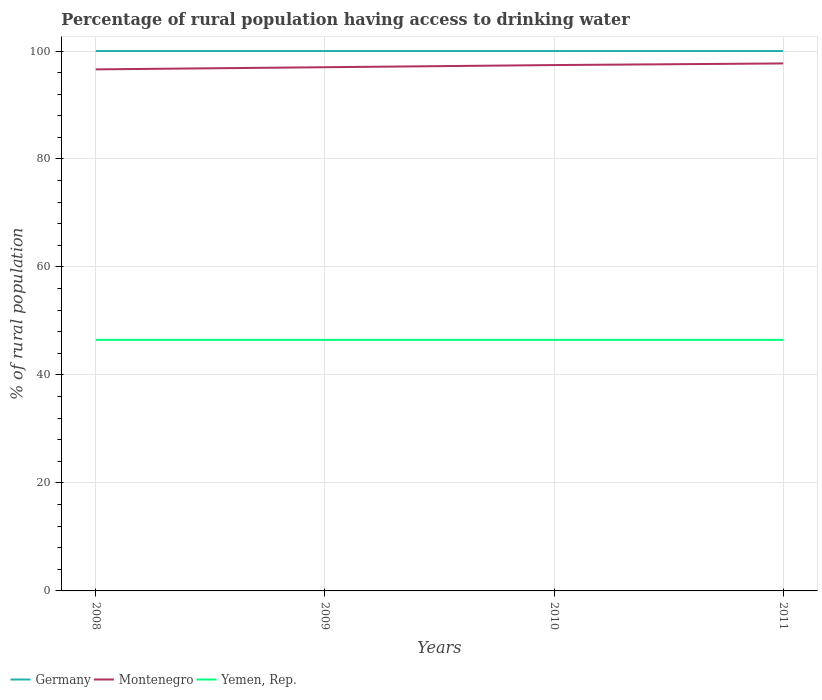Is the number of lines equal to the number of legend labels?
Provide a short and direct response. Yes. Across all years, what is the maximum percentage of rural population having access to drinking water in Montenegro?
Provide a short and direct response. 96.6. What is the total percentage of rural population having access to drinking water in Montenegro in the graph?
Give a very brief answer. -0.8. What is the difference between the highest and the second highest percentage of rural population having access to drinking water in Montenegro?
Provide a short and direct response. 1.1. What is the title of the graph?
Your response must be concise. Percentage of rural population having access to drinking water. Does "Maldives" appear as one of the legend labels in the graph?
Ensure brevity in your answer.  No. What is the label or title of the X-axis?
Offer a very short reply. Years. What is the label or title of the Y-axis?
Offer a terse response. % of rural population. What is the % of rural population of Montenegro in 2008?
Offer a terse response. 96.6. What is the % of rural population of Yemen, Rep. in 2008?
Your answer should be compact. 46.5. What is the % of rural population in Germany in 2009?
Ensure brevity in your answer.  100. What is the % of rural population in Montenegro in 2009?
Make the answer very short. 97. What is the % of rural population in Yemen, Rep. in 2009?
Your answer should be very brief. 46.5. What is the % of rural population in Montenegro in 2010?
Give a very brief answer. 97.4. What is the % of rural population of Yemen, Rep. in 2010?
Keep it short and to the point. 46.5. What is the % of rural population in Germany in 2011?
Give a very brief answer. 100. What is the % of rural population in Montenegro in 2011?
Keep it short and to the point. 97.7. What is the % of rural population in Yemen, Rep. in 2011?
Give a very brief answer. 46.5. Across all years, what is the maximum % of rural population in Montenegro?
Keep it short and to the point. 97.7. Across all years, what is the maximum % of rural population in Yemen, Rep.?
Your answer should be very brief. 46.5. Across all years, what is the minimum % of rural population in Germany?
Provide a short and direct response. 100. Across all years, what is the minimum % of rural population in Montenegro?
Ensure brevity in your answer.  96.6. Across all years, what is the minimum % of rural population of Yemen, Rep.?
Give a very brief answer. 46.5. What is the total % of rural population of Montenegro in the graph?
Offer a very short reply. 388.7. What is the total % of rural population in Yemen, Rep. in the graph?
Ensure brevity in your answer.  186. What is the difference between the % of rural population of Germany in 2008 and that in 2009?
Provide a succinct answer. 0. What is the difference between the % of rural population in Yemen, Rep. in 2008 and that in 2009?
Provide a short and direct response. 0. What is the difference between the % of rural population in Germany in 2008 and that in 2010?
Keep it short and to the point. 0. What is the difference between the % of rural population of Yemen, Rep. in 2008 and that in 2010?
Your response must be concise. 0. What is the difference between the % of rural population of Germany in 2008 and that in 2011?
Provide a succinct answer. 0. What is the difference between the % of rural population in Yemen, Rep. in 2008 and that in 2011?
Provide a succinct answer. 0. What is the difference between the % of rural population of Germany in 2009 and that in 2010?
Ensure brevity in your answer.  0. What is the difference between the % of rural population in Montenegro in 2009 and that in 2010?
Make the answer very short. -0.4. What is the difference between the % of rural population of Yemen, Rep. in 2009 and that in 2010?
Ensure brevity in your answer.  0. What is the difference between the % of rural population in Montenegro in 2009 and that in 2011?
Your answer should be compact. -0.7. What is the difference between the % of rural population of Yemen, Rep. in 2009 and that in 2011?
Make the answer very short. 0. What is the difference between the % of rural population of Germany in 2008 and the % of rural population of Yemen, Rep. in 2009?
Provide a short and direct response. 53.5. What is the difference between the % of rural population of Montenegro in 2008 and the % of rural population of Yemen, Rep. in 2009?
Provide a succinct answer. 50.1. What is the difference between the % of rural population of Germany in 2008 and the % of rural population of Montenegro in 2010?
Provide a short and direct response. 2.6. What is the difference between the % of rural population of Germany in 2008 and the % of rural population of Yemen, Rep. in 2010?
Your answer should be very brief. 53.5. What is the difference between the % of rural population of Montenegro in 2008 and the % of rural population of Yemen, Rep. in 2010?
Give a very brief answer. 50.1. What is the difference between the % of rural population in Germany in 2008 and the % of rural population in Yemen, Rep. in 2011?
Ensure brevity in your answer.  53.5. What is the difference between the % of rural population in Montenegro in 2008 and the % of rural population in Yemen, Rep. in 2011?
Your response must be concise. 50.1. What is the difference between the % of rural population of Germany in 2009 and the % of rural population of Montenegro in 2010?
Your answer should be very brief. 2.6. What is the difference between the % of rural population of Germany in 2009 and the % of rural population of Yemen, Rep. in 2010?
Your response must be concise. 53.5. What is the difference between the % of rural population of Montenegro in 2009 and the % of rural population of Yemen, Rep. in 2010?
Your response must be concise. 50.5. What is the difference between the % of rural population in Germany in 2009 and the % of rural population in Montenegro in 2011?
Offer a terse response. 2.3. What is the difference between the % of rural population in Germany in 2009 and the % of rural population in Yemen, Rep. in 2011?
Your response must be concise. 53.5. What is the difference between the % of rural population in Montenegro in 2009 and the % of rural population in Yemen, Rep. in 2011?
Your answer should be very brief. 50.5. What is the difference between the % of rural population in Germany in 2010 and the % of rural population in Yemen, Rep. in 2011?
Offer a terse response. 53.5. What is the difference between the % of rural population of Montenegro in 2010 and the % of rural population of Yemen, Rep. in 2011?
Provide a succinct answer. 50.9. What is the average % of rural population of Germany per year?
Provide a short and direct response. 100. What is the average % of rural population in Montenegro per year?
Ensure brevity in your answer.  97.17. What is the average % of rural population of Yemen, Rep. per year?
Ensure brevity in your answer.  46.5. In the year 2008, what is the difference between the % of rural population in Germany and % of rural population in Yemen, Rep.?
Keep it short and to the point. 53.5. In the year 2008, what is the difference between the % of rural population of Montenegro and % of rural population of Yemen, Rep.?
Give a very brief answer. 50.1. In the year 2009, what is the difference between the % of rural population of Germany and % of rural population of Yemen, Rep.?
Your answer should be compact. 53.5. In the year 2009, what is the difference between the % of rural population of Montenegro and % of rural population of Yemen, Rep.?
Provide a succinct answer. 50.5. In the year 2010, what is the difference between the % of rural population in Germany and % of rural population in Montenegro?
Offer a terse response. 2.6. In the year 2010, what is the difference between the % of rural population of Germany and % of rural population of Yemen, Rep.?
Ensure brevity in your answer.  53.5. In the year 2010, what is the difference between the % of rural population of Montenegro and % of rural population of Yemen, Rep.?
Give a very brief answer. 50.9. In the year 2011, what is the difference between the % of rural population of Germany and % of rural population of Yemen, Rep.?
Your response must be concise. 53.5. In the year 2011, what is the difference between the % of rural population in Montenegro and % of rural population in Yemen, Rep.?
Your response must be concise. 51.2. What is the ratio of the % of rural population of Germany in 2008 to that in 2009?
Provide a succinct answer. 1. What is the ratio of the % of rural population of Montenegro in 2008 to that in 2009?
Provide a short and direct response. 1. What is the ratio of the % of rural population of Germany in 2008 to that in 2010?
Offer a very short reply. 1. What is the ratio of the % of rural population of Montenegro in 2008 to that in 2010?
Your answer should be very brief. 0.99. What is the ratio of the % of rural population of Yemen, Rep. in 2008 to that in 2010?
Your answer should be very brief. 1. What is the ratio of the % of rural population of Germany in 2008 to that in 2011?
Ensure brevity in your answer.  1. What is the ratio of the % of rural population in Montenegro in 2008 to that in 2011?
Provide a succinct answer. 0.99. What is the ratio of the % of rural population in Yemen, Rep. in 2008 to that in 2011?
Offer a very short reply. 1. What is the ratio of the % of rural population in Montenegro in 2009 to that in 2010?
Your answer should be very brief. 1. What is the ratio of the % of rural population of Yemen, Rep. in 2009 to that in 2010?
Offer a very short reply. 1. What is the ratio of the % of rural population in Montenegro in 2009 to that in 2011?
Provide a short and direct response. 0.99. What is the ratio of the % of rural population of Yemen, Rep. in 2009 to that in 2011?
Offer a very short reply. 1. What is the difference between the highest and the second highest % of rural population in Germany?
Your answer should be very brief. 0. What is the difference between the highest and the second highest % of rural population of Montenegro?
Your answer should be compact. 0.3. What is the difference between the highest and the second highest % of rural population of Yemen, Rep.?
Offer a terse response. 0. 